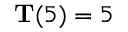<formula> <loc_0><loc_0><loc_500><loc_500>T ( 5 ) = 5</formula> 